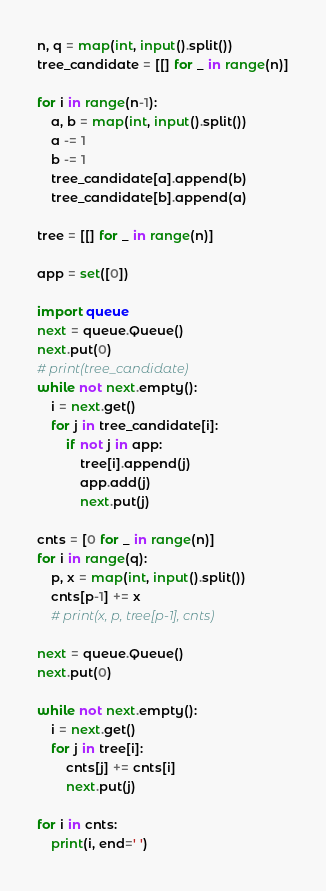Convert code to text. <code><loc_0><loc_0><loc_500><loc_500><_Python_>n, q = map(int, input().split())
tree_candidate = [[] for _ in range(n)]

for i in range(n-1):
    a, b = map(int, input().split())
    a -= 1
    b -= 1
    tree_candidate[a].append(b)
    tree_candidate[b].append(a)

tree = [[] for _ in range(n)]

app = set([0])

import queue
next = queue.Queue()
next.put(0)
# print(tree_candidate)
while not next.empty():
    i = next.get()
    for j in tree_candidate[i]:
        if not j in app:
            tree[i].append(j)
            app.add(j)
            next.put(j)

cnts = [0 for _ in range(n)]
for i in range(q):
    p, x = map(int, input().split())
    cnts[p-1] += x
    # print(x, p, tree[p-1], cnts)

next = queue.Queue()
next.put(0)

while not next.empty():
    i = next.get()
    for j in tree[i]:
        cnts[j] += cnts[i]
        next.put(j)

for i in cnts:
    print(i, end=' ')</code> 